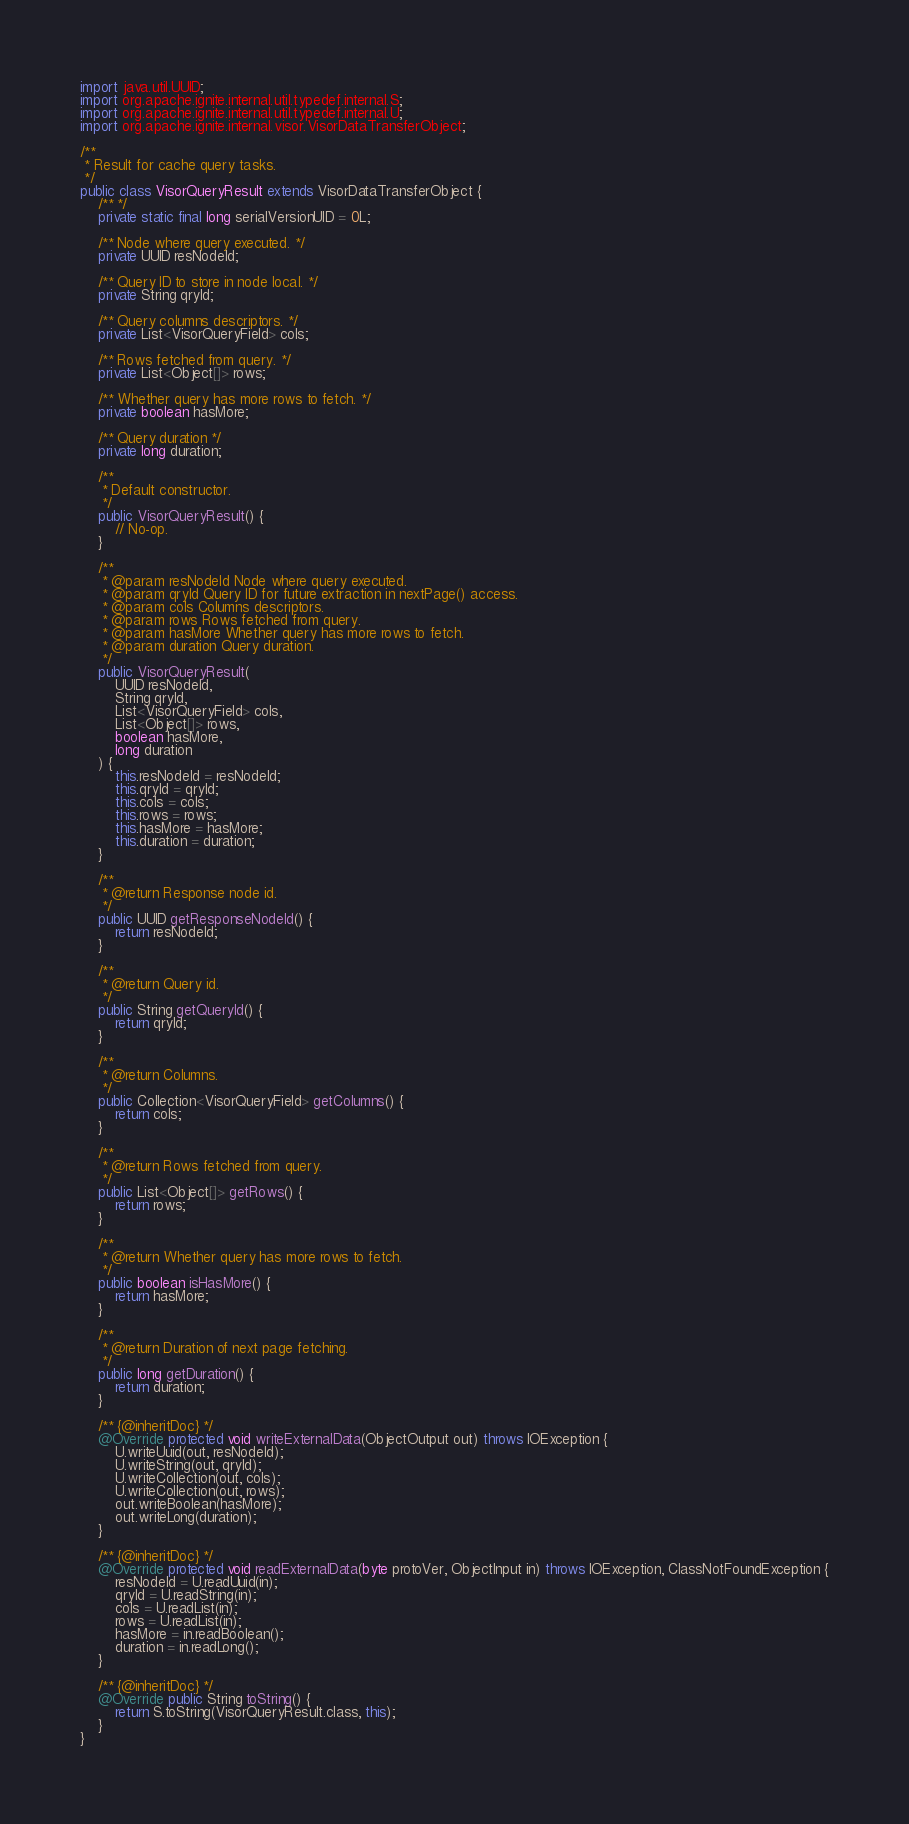<code> <loc_0><loc_0><loc_500><loc_500><_Java_>import java.util.UUID;
import org.apache.ignite.internal.util.typedef.internal.S;
import org.apache.ignite.internal.util.typedef.internal.U;
import org.apache.ignite.internal.visor.VisorDataTransferObject;

/**
 * Result for cache query tasks.
 */
public class VisorQueryResult extends VisorDataTransferObject {
    /** */
    private static final long serialVersionUID = 0L;

    /** Node where query executed. */
    private UUID resNodeId;

    /** Query ID to store in node local. */
    private String qryId;

    /** Query columns descriptors. */
    private List<VisorQueryField> cols;

    /** Rows fetched from query. */
    private List<Object[]> rows;

    /** Whether query has more rows to fetch. */
    private boolean hasMore;

    /** Query duration */
    private long duration;

    /**
     * Default constructor.
     */
    public VisorQueryResult() {
        // No-op.
    }

    /**
     * @param resNodeId Node where query executed.
     * @param qryId Query ID for future extraction in nextPage() access.
     * @param cols Columns descriptors.
     * @param rows Rows fetched from query.
     * @param hasMore Whether query has more rows to fetch.
     * @param duration Query duration.
     */
    public VisorQueryResult(
        UUID resNodeId,
        String qryId,
        List<VisorQueryField> cols,
        List<Object[]> rows,
        boolean hasMore,
        long duration
    ) {
        this.resNodeId = resNodeId;
        this.qryId = qryId;
        this.cols = cols;
        this.rows = rows;
        this.hasMore = hasMore;
        this.duration = duration;
    }

    /**
     * @return Response node id.
     */
    public UUID getResponseNodeId() {
        return resNodeId;
    }

    /**
     * @return Query id.
     */
    public String getQueryId() {
        return qryId;
    }

    /**
     * @return Columns.
     */
    public Collection<VisorQueryField> getColumns() {
        return cols;
    }

    /**
     * @return Rows fetched from query.
     */
    public List<Object[]> getRows() {
        return rows;
    }

    /**
     * @return Whether query has more rows to fetch.
     */
    public boolean isHasMore() {
        return hasMore;
    }

    /**
     * @return Duration of next page fetching.
     */
    public long getDuration() {
        return duration;
    }

    /** {@inheritDoc} */
    @Override protected void writeExternalData(ObjectOutput out) throws IOException {
        U.writeUuid(out, resNodeId);
        U.writeString(out, qryId);
        U.writeCollection(out, cols);
        U.writeCollection(out, rows);
        out.writeBoolean(hasMore);
        out.writeLong(duration);
    }

    /** {@inheritDoc} */
    @Override protected void readExternalData(byte protoVer, ObjectInput in) throws IOException, ClassNotFoundException {
        resNodeId = U.readUuid(in);
        qryId = U.readString(in);
        cols = U.readList(in);
        rows = U.readList(in);
        hasMore = in.readBoolean();
        duration = in.readLong();
    }

    /** {@inheritDoc} */
    @Override public String toString() {
        return S.toString(VisorQueryResult.class, this);
    }
}
</code> 